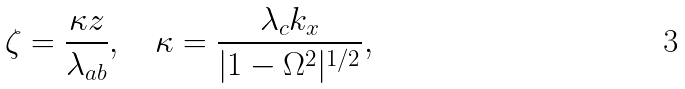<formula> <loc_0><loc_0><loc_500><loc_500>\zeta = \frac { \kappa z } { \lambda _ { a b } } , \quad \kappa = \frac { \lambda _ { c } k _ { x } } { | 1 - \Omega ^ { 2 } | ^ { 1 / 2 } } ,</formula> 